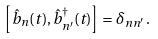<formula> <loc_0><loc_0><loc_500><loc_500>\left [ \hat { b } _ { n } ( t ) , \hat { b } _ { n ^ { \prime } } ^ { \dagger } ( t ) \right ] = \delta _ { n n ^ { \prime } } \, .</formula> 